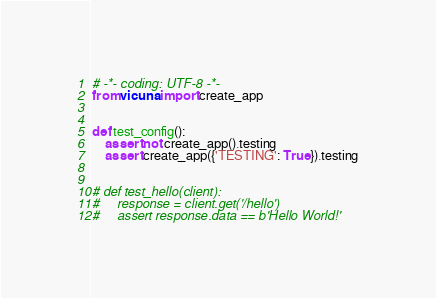Convert code to text. <code><loc_0><loc_0><loc_500><loc_500><_Python_># -*- coding: UTF-8 -*-
from vicuna import create_app


def test_config():
    assert not create_app().testing
    assert create_app({'TESTING': True}).testing


# def test_hello(client):
#     response = client.get('/hello')
#     assert response.data == b'Hello World!'
</code> 